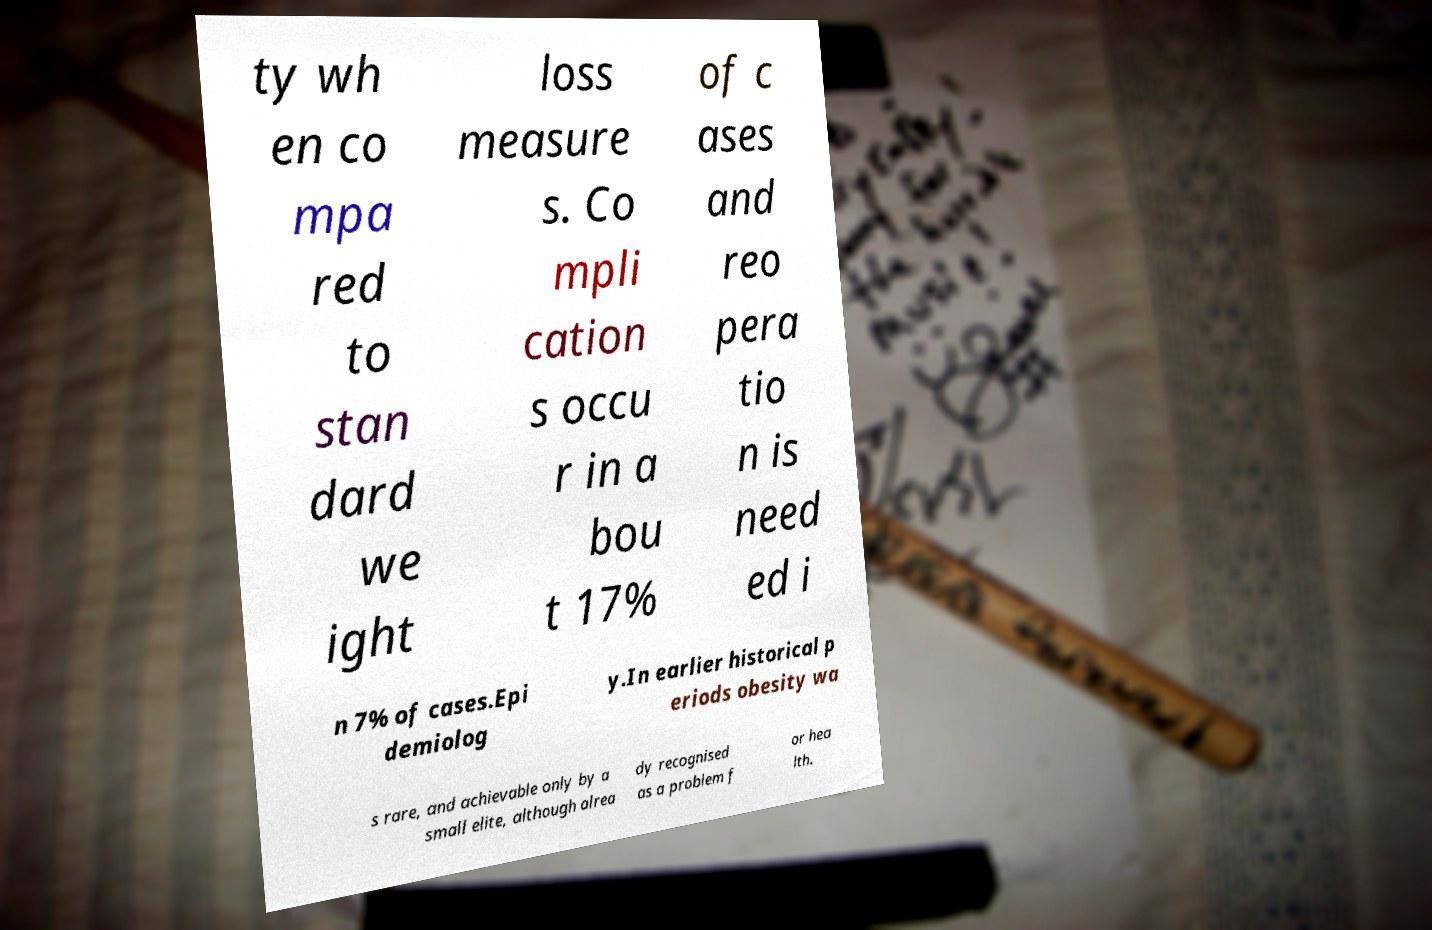Could you assist in decoding the text presented in this image and type it out clearly? ty wh en co mpa red to stan dard we ight loss measure s. Co mpli cation s occu r in a bou t 17% of c ases and reo pera tio n is need ed i n 7% of cases.Epi demiolog y.In earlier historical p eriods obesity wa s rare, and achievable only by a small elite, although alrea dy recognised as a problem f or hea lth. 